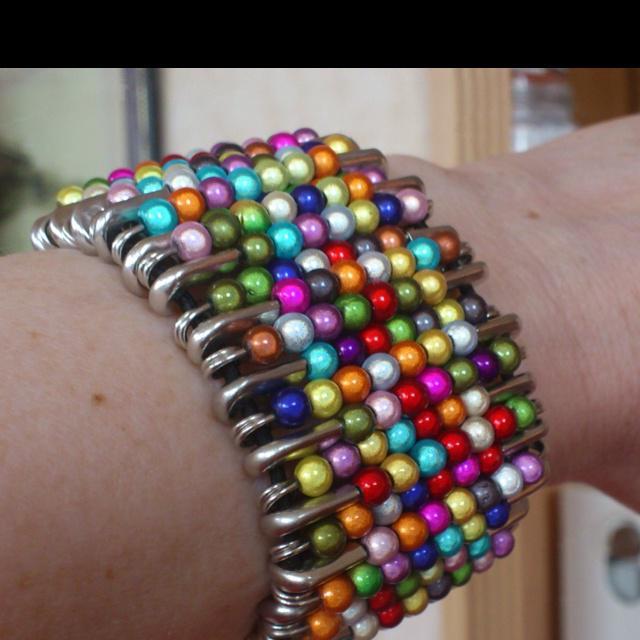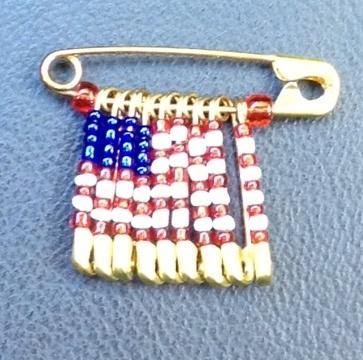The first image is the image on the left, the second image is the image on the right. Given the left and right images, does the statement "A bracelet made of pins is worn on a wrist in the image on the left." hold true? Answer yes or no. Yes. The first image is the image on the left, the second image is the image on the right. Assess this claim about the two images: "An image shows only one decorative pin with a pattern created by dangling pins strung with beads.". Correct or not? Answer yes or no. Yes. 